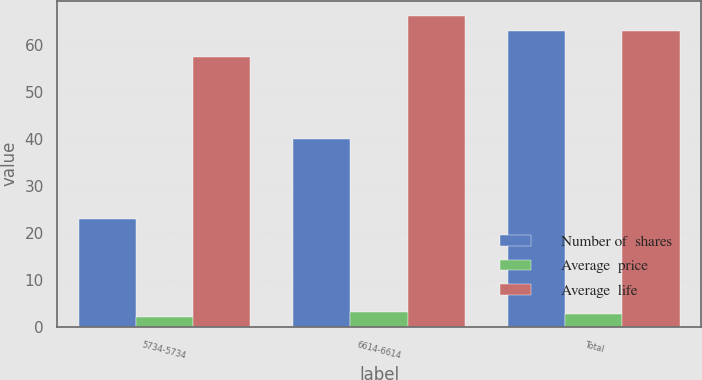Convert chart to OTSL. <chart><loc_0><loc_0><loc_500><loc_500><stacked_bar_chart><ecel><fcel>5734-5734<fcel>6614-6614<fcel>Total<nl><fcel>Number of  shares<fcel>23<fcel>40<fcel>63<nl><fcel>Average  price<fcel>2.15<fcel>3.14<fcel>2.77<nl><fcel>Average  life<fcel>57.34<fcel>66.14<fcel>62.86<nl></chart> 